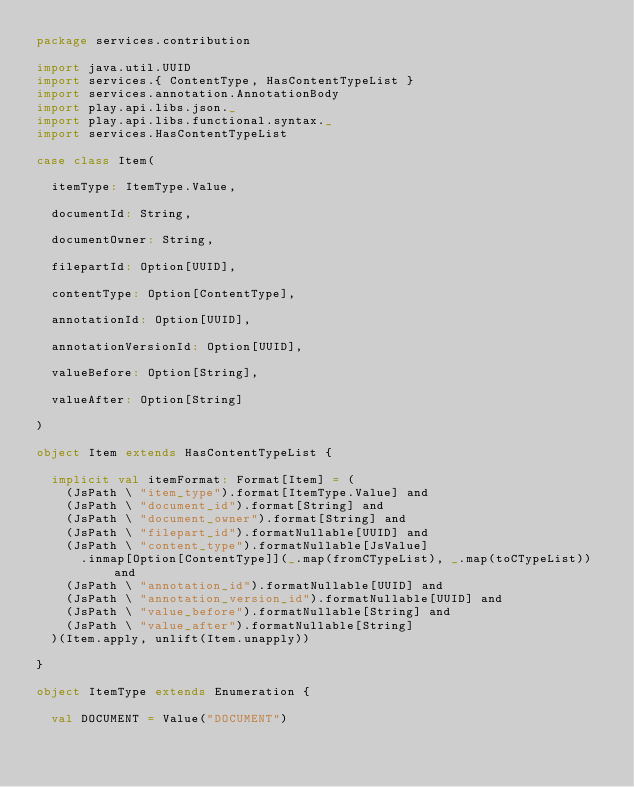Convert code to text. <code><loc_0><loc_0><loc_500><loc_500><_Scala_>package services.contribution

import java.util.UUID
import services.{ ContentType, HasContentTypeList }
import services.annotation.AnnotationBody
import play.api.libs.json._
import play.api.libs.functional.syntax._
import services.HasContentTypeList

case class Item(
  
  itemType: ItemType.Value,
  
  documentId: String,
  
  documentOwner: String,
  
  filepartId: Option[UUID],
  
  contentType: Option[ContentType],
  
  annotationId: Option[UUID],
  
  annotationVersionId: Option[UUID],
  
  valueBefore: Option[String],
  
  valueAfter: Option[String]
  
)

object Item extends HasContentTypeList {
  
  implicit val itemFormat: Format[Item] = (
    (JsPath \ "item_type").format[ItemType.Value] and
    (JsPath \ "document_id").format[String] and
    (JsPath \ "document_owner").format[String] and
    (JsPath \ "filepart_id").formatNullable[UUID] and
    (JsPath \ "content_type").formatNullable[JsValue]
      .inmap[Option[ContentType]](_.map(fromCTypeList), _.map(toCTypeList)) and
    (JsPath \ "annotation_id").formatNullable[UUID] and
    (JsPath \ "annotation_version_id").formatNullable[UUID] and
    (JsPath \ "value_before").formatNullable[String] and
    (JsPath \ "value_after").formatNullable[String]
  )(Item.apply, unlift(Item.unapply))

}
  
object ItemType extends Enumeration {

  val DOCUMENT = Value("DOCUMENT")
</code> 